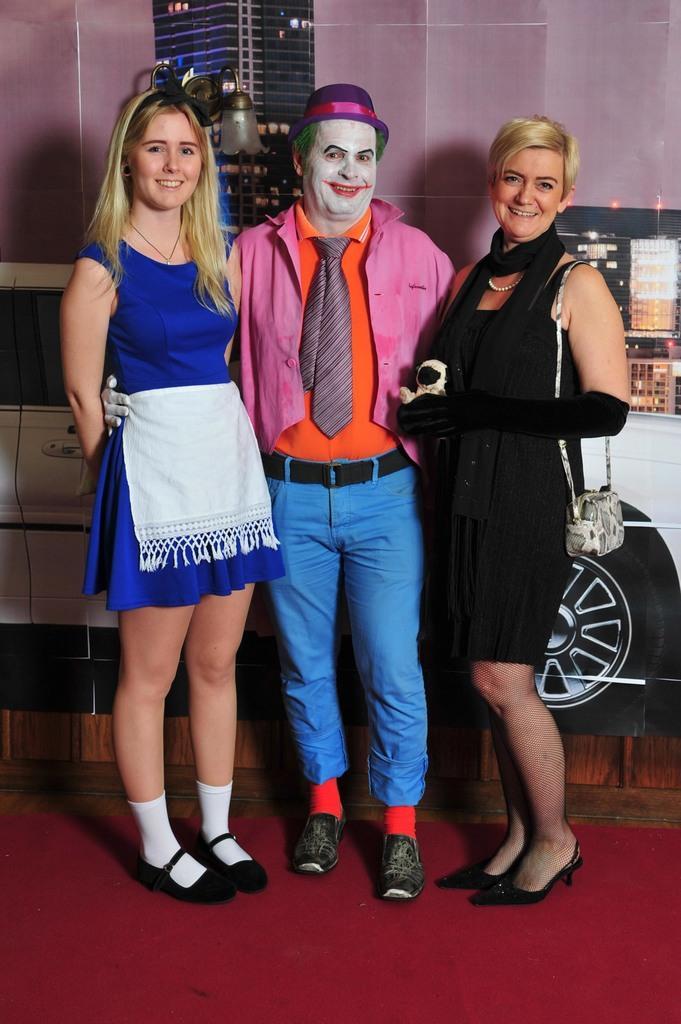Describe this image in one or two sentences. In this image I can see three persons are standing and I can also see face painting on one's face. On the right side I can see one of them is carrying a bag and I can also see smile on their faces. In the background I can see depiction of a car, few posters and I can also see a light on the wall. 